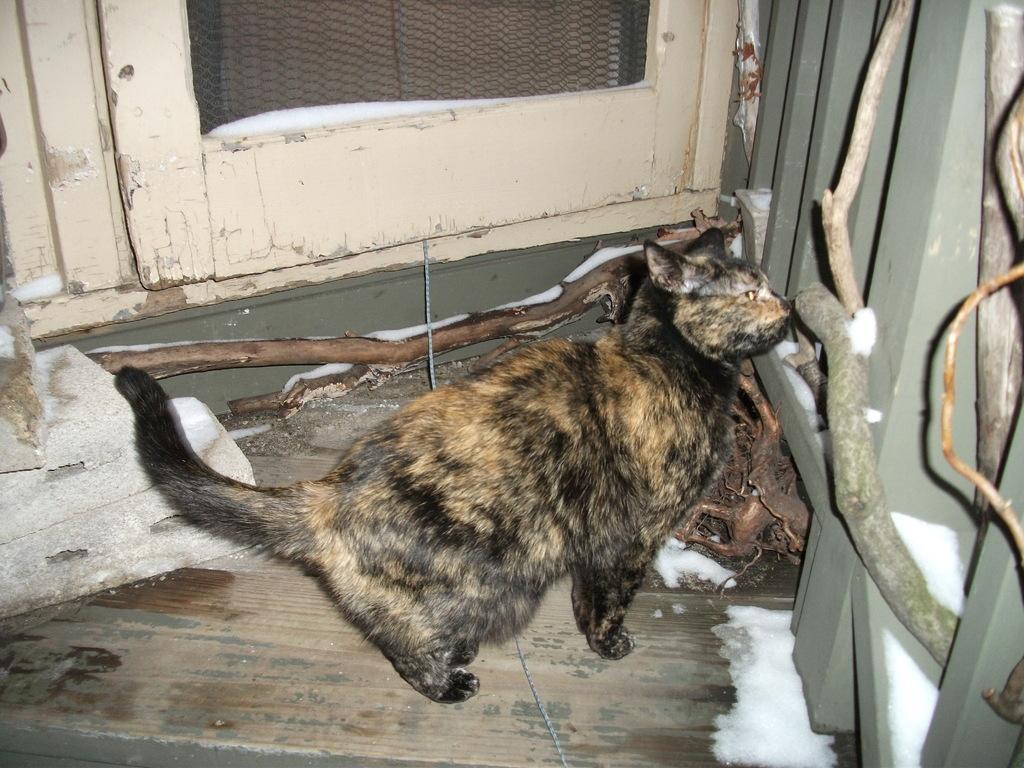Please provide a concise description of this image. In the image there is a cat and behind the cat there is a door, on the right side there is a railing. 